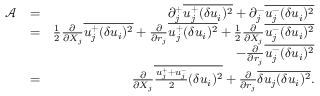<formula> <loc_0><loc_0><loc_500><loc_500>\begin{array} { r l r } { \mathcal { A } } & { = } & { \partial _ { j } ^ { + } \overline { { u _ { j } ^ { + } ( \delta u _ { i } ) ^ { 2 } } } + \partial _ { j } ^ { - } \overline { { u _ { j } ^ { - } ( \delta u _ { i } ) ^ { 2 } } } } \\ & { = } & { \frac { 1 } { 2 } \frac { \partial } { \partial { X _ { j } } } \overline { { u _ { j } ^ { + } ( \delta u _ { i } ) ^ { 2 } } } + \frac { \partial } { \partial { r _ { j } } } \overline { { u _ { j } ^ { + } ( \delta u _ { i } ) ^ { 2 } } } + \frac { 1 } { 2 } \frac { \partial } { \partial { X _ { j } } } \overline { { u _ { j } ^ { - } ( \delta u _ { i } ) ^ { 2 } } } } \\ & { - \frac { \partial } { \partial { r _ { j } } } \overline { { u _ { j } ^ { - } ( \delta u _ { i } ) ^ { 2 } } } } \\ & { = } & { \frac { \partial } { \partial { X _ { j } } } \overline { { \frac { u _ { j } ^ { + } + u _ { j } ^ { - } } { 2 } ( \delta u _ { i } ) ^ { 2 } } } + \frac { \partial } { \partial { r _ { j } } } \overline { { \delta u _ { j } ( \delta u _ { i } ) ^ { 2 } } } . } \end{array}</formula> 